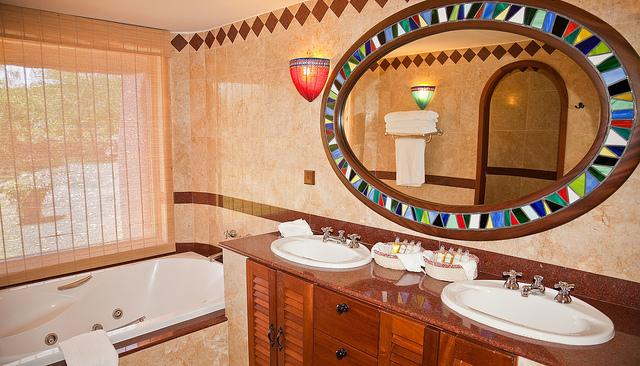What materials likely make up the colorful frame of the mirror? glass 